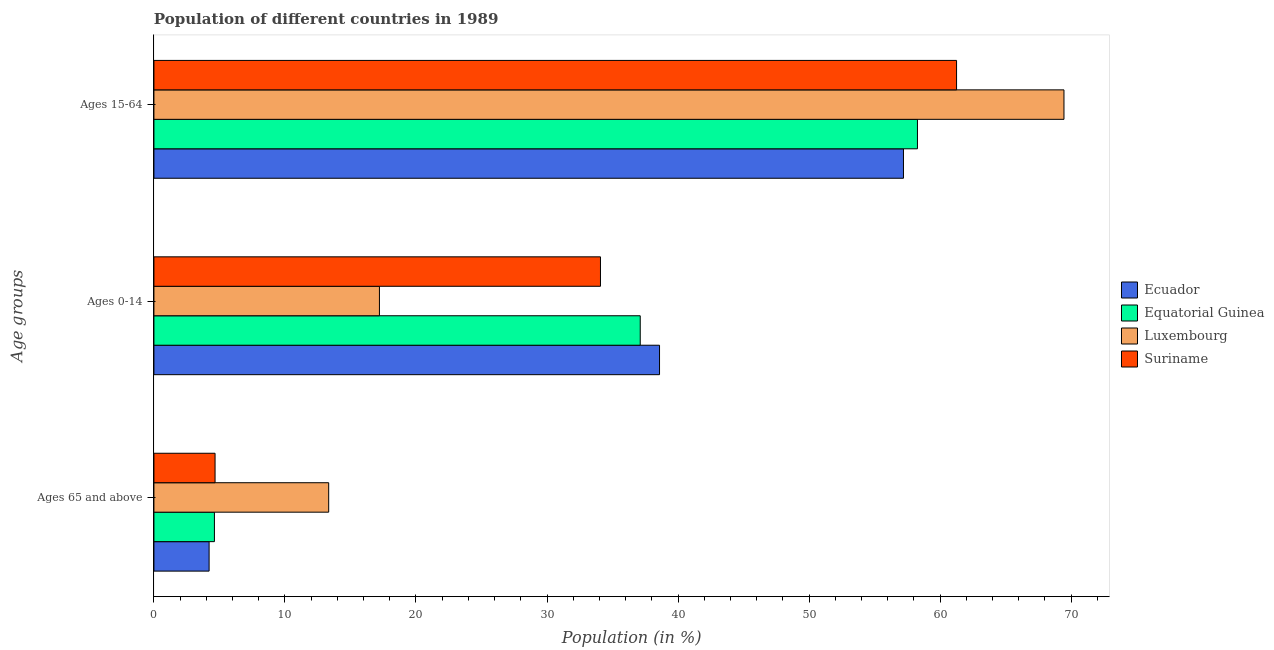How many different coloured bars are there?
Offer a terse response. 4. How many groups of bars are there?
Offer a terse response. 3. Are the number of bars per tick equal to the number of legend labels?
Your answer should be compact. Yes. What is the label of the 3rd group of bars from the top?
Offer a terse response. Ages 65 and above. What is the percentage of population within the age-group 0-14 in Ecuador?
Keep it short and to the point. 38.59. Across all countries, what is the maximum percentage of population within the age-group 15-64?
Ensure brevity in your answer.  69.45. Across all countries, what is the minimum percentage of population within the age-group 15-64?
Give a very brief answer. 57.2. In which country was the percentage of population within the age-group 15-64 maximum?
Ensure brevity in your answer.  Luxembourg. In which country was the percentage of population within the age-group of 65 and above minimum?
Your answer should be compact. Ecuador. What is the total percentage of population within the age-group 15-64 in the graph?
Your answer should be compact. 246.18. What is the difference between the percentage of population within the age-group 15-64 in Luxembourg and that in Equatorial Guinea?
Your answer should be compact. 11.18. What is the difference between the percentage of population within the age-group 0-14 in Ecuador and the percentage of population within the age-group of 65 and above in Luxembourg?
Your answer should be very brief. 25.25. What is the average percentage of population within the age-group 15-64 per country?
Keep it short and to the point. 61.54. What is the difference between the percentage of population within the age-group 15-64 and percentage of population within the age-group 0-14 in Equatorial Guinea?
Give a very brief answer. 21.16. What is the ratio of the percentage of population within the age-group 15-64 in Suriname to that in Ecuador?
Offer a terse response. 1.07. What is the difference between the highest and the second highest percentage of population within the age-group of 65 and above?
Make the answer very short. 8.67. What is the difference between the highest and the lowest percentage of population within the age-group 0-14?
Keep it short and to the point. 21.38. Is the sum of the percentage of population within the age-group of 65 and above in Equatorial Guinea and Ecuador greater than the maximum percentage of population within the age-group 15-64 across all countries?
Provide a succinct answer. No. What does the 4th bar from the top in Ages 15-64 represents?
Offer a very short reply. Ecuador. What does the 4th bar from the bottom in Ages 65 and above represents?
Offer a terse response. Suriname. Is it the case that in every country, the sum of the percentage of population within the age-group of 65 and above and percentage of population within the age-group 0-14 is greater than the percentage of population within the age-group 15-64?
Your answer should be very brief. No. How many countries are there in the graph?
Make the answer very short. 4. Are the values on the major ticks of X-axis written in scientific E-notation?
Your answer should be very brief. No. Does the graph contain any zero values?
Keep it short and to the point. No. How many legend labels are there?
Your answer should be compact. 4. What is the title of the graph?
Ensure brevity in your answer.  Population of different countries in 1989. What is the label or title of the Y-axis?
Make the answer very short. Age groups. What is the Population (in %) in Ecuador in Ages 65 and above?
Offer a very short reply. 4.21. What is the Population (in %) of Equatorial Guinea in Ages 65 and above?
Provide a short and direct response. 4.62. What is the Population (in %) of Luxembourg in Ages 65 and above?
Offer a terse response. 13.34. What is the Population (in %) of Suriname in Ages 65 and above?
Keep it short and to the point. 4.67. What is the Population (in %) of Ecuador in Ages 0-14?
Your answer should be compact. 38.59. What is the Population (in %) of Equatorial Guinea in Ages 0-14?
Provide a short and direct response. 37.11. What is the Population (in %) in Luxembourg in Ages 0-14?
Provide a short and direct response. 17.21. What is the Population (in %) of Suriname in Ages 0-14?
Your response must be concise. 34.08. What is the Population (in %) in Ecuador in Ages 15-64?
Provide a succinct answer. 57.2. What is the Population (in %) of Equatorial Guinea in Ages 15-64?
Ensure brevity in your answer.  58.27. What is the Population (in %) in Luxembourg in Ages 15-64?
Ensure brevity in your answer.  69.45. What is the Population (in %) of Suriname in Ages 15-64?
Your answer should be very brief. 61.25. Across all Age groups, what is the maximum Population (in %) of Ecuador?
Offer a terse response. 57.2. Across all Age groups, what is the maximum Population (in %) in Equatorial Guinea?
Give a very brief answer. 58.27. Across all Age groups, what is the maximum Population (in %) in Luxembourg?
Offer a very short reply. 69.45. Across all Age groups, what is the maximum Population (in %) of Suriname?
Provide a succinct answer. 61.25. Across all Age groups, what is the minimum Population (in %) in Ecuador?
Offer a terse response. 4.21. Across all Age groups, what is the minimum Population (in %) of Equatorial Guinea?
Offer a very short reply. 4.62. Across all Age groups, what is the minimum Population (in %) in Luxembourg?
Your answer should be compact. 13.34. Across all Age groups, what is the minimum Population (in %) in Suriname?
Ensure brevity in your answer.  4.67. What is the total Population (in %) in Ecuador in the graph?
Provide a short and direct response. 100. What is the total Population (in %) in Equatorial Guinea in the graph?
Offer a terse response. 100. What is the difference between the Population (in %) in Ecuador in Ages 65 and above and that in Ages 0-14?
Offer a terse response. -34.38. What is the difference between the Population (in %) of Equatorial Guinea in Ages 65 and above and that in Ages 0-14?
Your response must be concise. -32.5. What is the difference between the Population (in %) in Luxembourg in Ages 65 and above and that in Ages 0-14?
Your answer should be very brief. -3.87. What is the difference between the Population (in %) in Suriname in Ages 65 and above and that in Ages 0-14?
Provide a short and direct response. -29.41. What is the difference between the Population (in %) in Ecuador in Ages 65 and above and that in Ages 15-64?
Your answer should be compact. -52.99. What is the difference between the Population (in %) in Equatorial Guinea in Ages 65 and above and that in Ages 15-64?
Ensure brevity in your answer.  -53.65. What is the difference between the Population (in %) of Luxembourg in Ages 65 and above and that in Ages 15-64?
Give a very brief answer. -56.11. What is the difference between the Population (in %) in Suriname in Ages 65 and above and that in Ages 15-64?
Ensure brevity in your answer.  -56.59. What is the difference between the Population (in %) in Ecuador in Ages 0-14 and that in Ages 15-64?
Offer a terse response. -18.62. What is the difference between the Population (in %) in Equatorial Guinea in Ages 0-14 and that in Ages 15-64?
Offer a very short reply. -21.16. What is the difference between the Population (in %) of Luxembourg in Ages 0-14 and that in Ages 15-64?
Offer a very short reply. -52.24. What is the difference between the Population (in %) in Suriname in Ages 0-14 and that in Ages 15-64?
Your answer should be compact. -27.18. What is the difference between the Population (in %) in Ecuador in Ages 65 and above and the Population (in %) in Equatorial Guinea in Ages 0-14?
Your answer should be compact. -32.9. What is the difference between the Population (in %) of Ecuador in Ages 65 and above and the Population (in %) of Luxembourg in Ages 0-14?
Offer a very short reply. -13. What is the difference between the Population (in %) of Ecuador in Ages 65 and above and the Population (in %) of Suriname in Ages 0-14?
Provide a succinct answer. -29.87. What is the difference between the Population (in %) of Equatorial Guinea in Ages 65 and above and the Population (in %) of Luxembourg in Ages 0-14?
Your response must be concise. -12.59. What is the difference between the Population (in %) in Equatorial Guinea in Ages 65 and above and the Population (in %) in Suriname in Ages 0-14?
Offer a very short reply. -29.46. What is the difference between the Population (in %) in Luxembourg in Ages 65 and above and the Population (in %) in Suriname in Ages 0-14?
Your response must be concise. -20.74. What is the difference between the Population (in %) of Ecuador in Ages 65 and above and the Population (in %) of Equatorial Guinea in Ages 15-64?
Ensure brevity in your answer.  -54.06. What is the difference between the Population (in %) of Ecuador in Ages 65 and above and the Population (in %) of Luxembourg in Ages 15-64?
Offer a terse response. -65.24. What is the difference between the Population (in %) of Ecuador in Ages 65 and above and the Population (in %) of Suriname in Ages 15-64?
Your answer should be very brief. -57.04. What is the difference between the Population (in %) of Equatorial Guinea in Ages 65 and above and the Population (in %) of Luxembourg in Ages 15-64?
Keep it short and to the point. -64.84. What is the difference between the Population (in %) in Equatorial Guinea in Ages 65 and above and the Population (in %) in Suriname in Ages 15-64?
Ensure brevity in your answer.  -56.64. What is the difference between the Population (in %) of Luxembourg in Ages 65 and above and the Population (in %) of Suriname in Ages 15-64?
Your answer should be very brief. -47.92. What is the difference between the Population (in %) in Ecuador in Ages 0-14 and the Population (in %) in Equatorial Guinea in Ages 15-64?
Your response must be concise. -19.68. What is the difference between the Population (in %) of Ecuador in Ages 0-14 and the Population (in %) of Luxembourg in Ages 15-64?
Provide a succinct answer. -30.87. What is the difference between the Population (in %) in Ecuador in Ages 0-14 and the Population (in %) in Suriname in Ages 15-64?
Provide a short and direct response. -22.67. What is the difference between the Population (in %) in Equatorial Guinea in Ages 0-14 and the Population (in %) in Luxembourg in Ages 15-64?
Your answer should be compact. -32.34. What is the difference between the Population (in %) in Equatorial Guinea in Ages 0-14 and the Population (in %) in Suriname in Ages 15-64?
Offer a terse response. -24.14. What is the difference between the Population (in %) in Luxembourg in Ages 0-14 and the Population (in %) in Suriname in Ages 15-64?
Provide a short and direct response. -44.04. What is the average Population (in %) of Ecuador per Age groups?
Your response must be concise. 33.33. What is the average Population (in %) in Equatorial Guinea per Age groups?
Your answer should be very brief. 33.33. What is the average Population (in %) in Luxembourg per Age groups?
Keep it short and to the point. 33.33. What is the average Population (in %) in Suriname per Age groups?
Offer a terse response. 33.33. What is the difference between the Population (in %) of Ecuador and Population (in %) of Equatorial Guinea in Ages 65 and above?
Your answer should be compact. -0.41. What is the difference between the Population (in %) of Ecuador and Population (in %) of Luxembourg in Ages 65 and above?
Your answer should be compact. -9.13. What is the difference between the Population (in %) of Ecuador and Population (in %) of Suriname in Ages 65 and above?
Offer a terse response. -0.45. What is the difference between the Population (in %) of Equatorial Guinea and Population (in %) of Luxembourg in Ages 65 and above?
Make the answer very short. -8.72. What is the difference between the Population (in %) of Equatorial Guinea and Population (in %) of Suriname in Ages 65 and above?
Keep it short and to the point. -0.05. What is the difference between the Population (in %) of Luxembourg and Population (in %) of Suriname in Ages 65 and above?
Offer a very short reply. 8.67. What is the difference between the Population (in %) of Ecuador and Population (in %) of Equatorial Guinea in Ages 0-14?
Ensure brevity in your answer.  1.47. What is the difference between the Population (in %) in Ecuador and Population (in %) in Luxembourg in Ages 0-14?
Your answer should be very brief. 21.38. What is the difference between the Population (in %) in Ecuador and Population (in %) in Suriname in Ages 0-14?
Keep it short and to the point. 4.51. What is the difference between the Population (in %) in Equatorial Guinea and Population (in %) in Luxembourg in Ages 0-14?
Provide a short and direct response. 19.9. What is the difference between the Population (in %) of Equatorial Guinea and Population (in %) of Suriname in Ages 0-14?
Your answer should be very brief. 3.03. What is the difference between the Population (in %) of Luxembourg and Population (in %) of Suriname in Ages 0-14?
Give a very brief answer. -16.87. What is the difference between the Population (in %) of Ecuador and Population (in %) of Equatorial Guinea in Ages 15-64?
Provide a succinct answer. -1.07. What is the difference between the Population (in %) of Ecuador and Population (in %) of Luxembourg in Ages 15-64?
Provide a succinct answer. -12.25. What is the difference between the Population (in %) of Ecuador and Population (in %) of Suriname in Ages 15-64?
Keep it short and to the point. -4.05. What is the difference between the Population (in %) in Equatorial Guinea and Population (in %) in Luxembourg in Ages 15-64?
Provide a short and direct response. -11.18. What is the difference between the Population (in %) in Equatorial Guinea and Population (in %) in Suriname in Ages 15-64?
Make the answer very short. -2.98. What is the difference between the Population (in %) in Luxembourg and Population (in %) in Suriname in Ages 15-64?
Give a very brief answer. 8.2. What is the ratio of the Population (in %) of Ecuador in Ages 65 and above to that in Ages 0-14?
Ensure brevity in your answer.  0.11. What is the ratio of the Population (in %) in Equatorial Guinea in Ages 65 and above to that in Ages 0-14?
Ensure brevity in your answer.  0.12. What is the ratio of the Population (in %) in Luxembourg in Ages 65 and above to that in Ages 0-14?
Make the answer very short. 0.78. What is the ratio of the Population (in %) in Suriname in Ages 65 and above to that in Ages 0-14?
Provide a short and direct response. 0.14. What is the ratio of the Population (in %) of Ecuador in Ages 65 and above to that in Ages 15-64?
Your response must be concise. 0.07. What is the ratio of the Population (in %) of Equatorial Guinea in Ages 65 and above to that in Ages 15-64?
Make the answer very short. 0.08. What is the ratio of the Population (in %) in Luxembourg in Ages 65 and above to that in Ages 15-64?
Provide a succinct answer. 0.19. What is the ratio of the Population (in %) of Suriname in Ages 65 and above to that in Ages 15-64?
Your answer should be compact. 0.08. What is the ratio of the Population (in %) in Ecuador in Ages 0-14 to that in Ages 15-64?
Make the answer very short. 0.67. What is the ratio of the Population (in %) of Equatorial Guinea in Ages 0-14 to that in Ages 15-64?
Keep it short and to the point. 0.64. What is the ratio of the Population (in %) in Luxembourg in Ages 0-14 to that in Ages 15-64?
Your response must be concise. 0.25. What is the ratio of the Population (in %) of Suriname in Ages 0-14 to that in Ages 15-64?
Offer a terse response. 0.56. What is the difference between the highest and the second highest Population (in %) of Ecuador?
Your answer should be compact. 18.62. What is the difference between the highest and the second highest Population (in %) of Equatorial Guinea?
Your response must be concise. 21.16. What is the difference between the highest and the second highest Population (in %) of Luxembourg?
Give a very brief answer. 52.24. What is the difference between the highest and the second highest Population (in %) of Suriname?
Provide a succinct answer. 27.18. What is the difference between the highest and the lowest Population (in %) in Ecuador?
Your answer should be very brief. 52.99. What is the difference between the highest and the lowest Population (in %) of Equatorial Guinea?
Your response must be concise. 53.65. What is the difference between the highest and the lowest Population (in %) in Luxembourg?
Offer a terse response. 56.11. What is the difference between the highest and the lowest Population (in %) in Suriname?
Offer a very short reply. 56.59. 